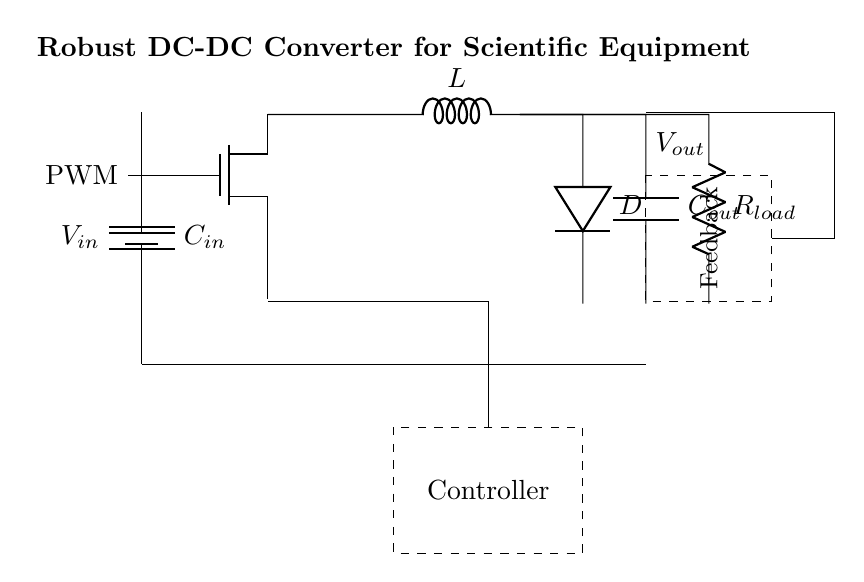What is the input voltage labeled in the diagram? The input voltage is labeled as V_in at the top of the battery symbol. This indicates the voltage supplied to the circuit from the vehicle battery.
Answer: V_in What type of switch is used in this circuit? The switch used in this circuit is a NMOS transistor, which is indicated in the diagram. This type of switch is effective for controlling higher power levels.
Answer: NMOS What does the inductor in this circuit do? The inductor L stores energy and is a key part of the DC-DC conversion process, which helps smooth out the current and regulate the output voltage.
Answer: Stores energy How does the circuit achieve feedback control? Feedback in this circuit is achieved through the dashed rectangle labeled "Feedback." This indicates the presence of a feedback loop that monitors output voltage and adjusts the PWM signal accordingly.
Answer: Feedback loop What is the role of the output capacitor? The output capacitor C_out is used to smooth the output voltage by reducing voltage ripple, ensuring a stable supply to the load connected at R_load.
Answer: Smooths output voltage What component rectifies the current in this circuit? The diode D is the component that rectifies the current, allowing current to flow in one direction and converting the AC-like signal generated by the switching inductor to a steady DC output.
Answer: Diode What is the load resistance connected in this circuit? The load resistance is labeled as R_load, which represents the scientific equipment that will draw power from the output of the converter circuit. The exact value is typically determined by the requirements of the specific equipment.
Answer: R_load 